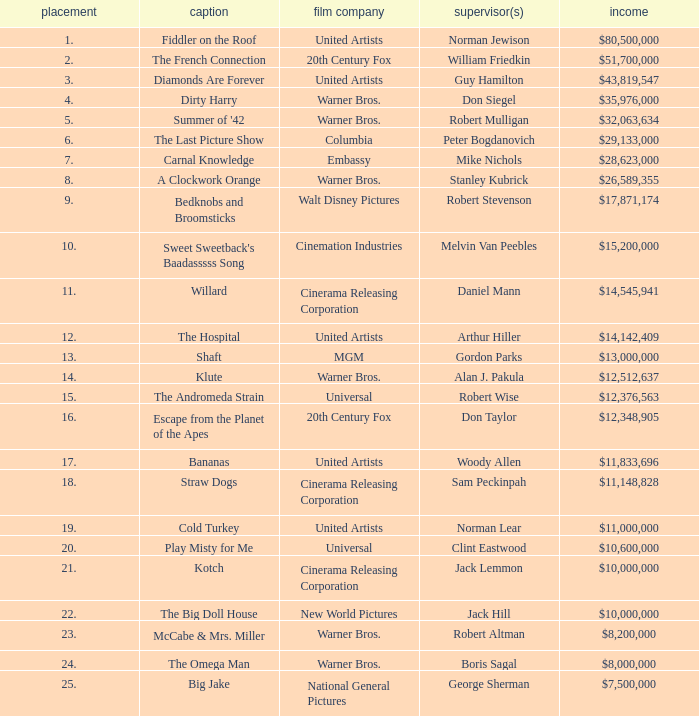Parse the table in full. {'header': ['placement', 'caption', 'film company', 'supervisor(s)', 'income'], 'rows': [['1.', 'Fiddler on the Roof', 'United Artists', 'Norman Jewison', '$80,500,000'], ['2.', 'The French Connection', '20th Century Fox', 'William Friedkin', '$51,700,000'], ['3.', 'Diamonds Are Forever', 'United Artists', 'Guy Hamilton', '$43,819,547'], ['4.', 'Dirty Harry', 'Warner Bros.', 'Don Siegel', '$35,976,000'], ['5.', "Summer of '42", 'Warner Bros.', 'Robert Mulligan', '$32,063,634'], ['6.', 'The Last Picture Show', 'Columbia', 'Peter Bogdanovich', '$29,133,000'], ['7.', 'Carnal Knowledge', 'Embassy', 'Mike Nichols', '$28,623,000'], ['8.', 'A Clockwork Orange', 'Warner Bros.', 'Stanley Kubrick', '$26,589,355'], ['9.', 'Bedknobs and Broomsticks', 'Walt Disney Pictures', 'Robert Stevenson', '$17,871,174'], ['10.', "Sweet Sweetback's Baadasssss Song", 'Cinemation Industries', 'Melvin Van Peebles', '$15,200,000'], ['11.', 'Willard', 'Cinerama Releasing Corporation', 'Daniel Mann', '$14,545,941'], ['12.', 'The Hospital', 'United Artists', 'Arthur Hiller', '$14,142,409'], ['13.', 'Shaft', 'MGM', 'Gordon Parks', '$13,000,000'], ['14.', 'Klute', 'Warner Bros.', 'Alan J. Pakula', '$12,512,637'], ['15.', 'The Andromeda Strain', 'Universal', 'Robert Wise', '$12,376,563'], ['16.', 'Escape from the Planet of the Apes', '20th Century Fox', 'Don Taylor', '$12,348,905'], ['17.', 'Bananas', 'United Artists', 'Woody Allen', '$11,833,696'], ['18.', 'Straw Dogs', 'Cinerama Releasing Corporation', 'Sam Peckinpah', '$11,148,828'], ['19.', 'Cold Turkey', 'United Artists', 'Norman Lear', '$11,000,000'], ['20.', 'Play Misty for Me', 'Universal', 'Clint Eastwood', '$10,600,000'], ['21.', 'Kotch', 'Cinerama Releasing Corporation', 'Jack Lemmon', '$10,000,000'], ['22.', 'The Big Doll House', 'New World Pictures', 'Jack Hill', '$10,000,000'], ['23.', 'McCabe & Mrs. Miller', 'Warner Bros.', 'Robert Altman', '$8,200,000'], ['24.', 'The Omega Man', 'Warner Bros.', 'Boris Sagal', '$8,000,000'], ['25.', 'Big Jake', 'National General Pictures', 'George Sherman', '$7,500,000']]} What ranking has a sum of $35,976,000? 4.0. 